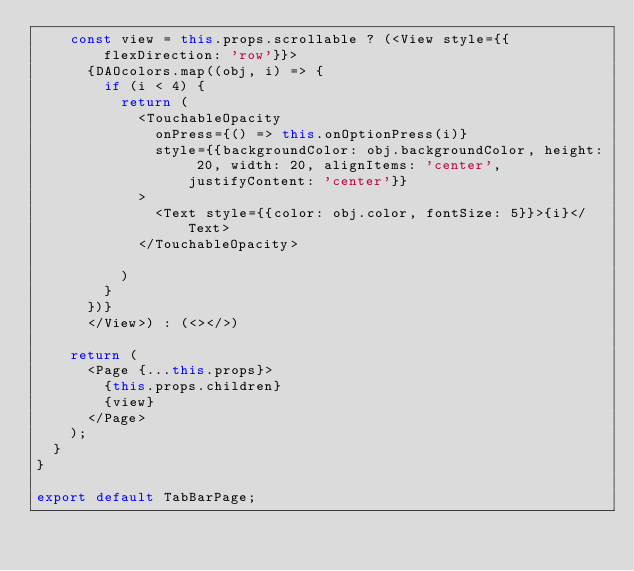Convert code to text. <code><loc_0><loc_0><loc_500><loc_500><_JavaScript_>    const view = this.props.scrollable ? (<View style={{flexDirection: 'row'}}>
      {DAOcolors.map((obj, i) => {
        if (i < 4) {
          return (
            <TouchableOpacity
              onPress={() => this.onOptionPress(i)}
              style={{backgroundColor: obj.backgroundColor, height: 20, width: 20, alignItems: 'center', justifyContent: 'center'}}
            >
              <Text style={{color: obj.color, fontSize: 5}}>{i}</Text>
            </TouchableOpacity>

          )
        }
      })}
      </View>) : (<></>)

    return (
      <Page {...this.props}>
        {this.props.children}
        {view}
      </Page>
    );
  }
}

export default TabBarPage;
</code> 